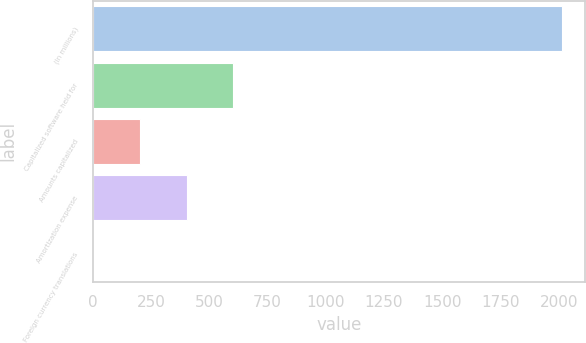<chart> <loc_0><loc_0><loc_500><loc_500><bar_chart><fcel>(In millions)<fcel>Capitalized software held for<fcel>Amounts capitalized<fcel>Amortization expense<fcel>Foreign currency translations<nl><fcel>2013<fcel>604.6<fcel>202.2<fcel>403.4<fcel>1<nl></chart> 